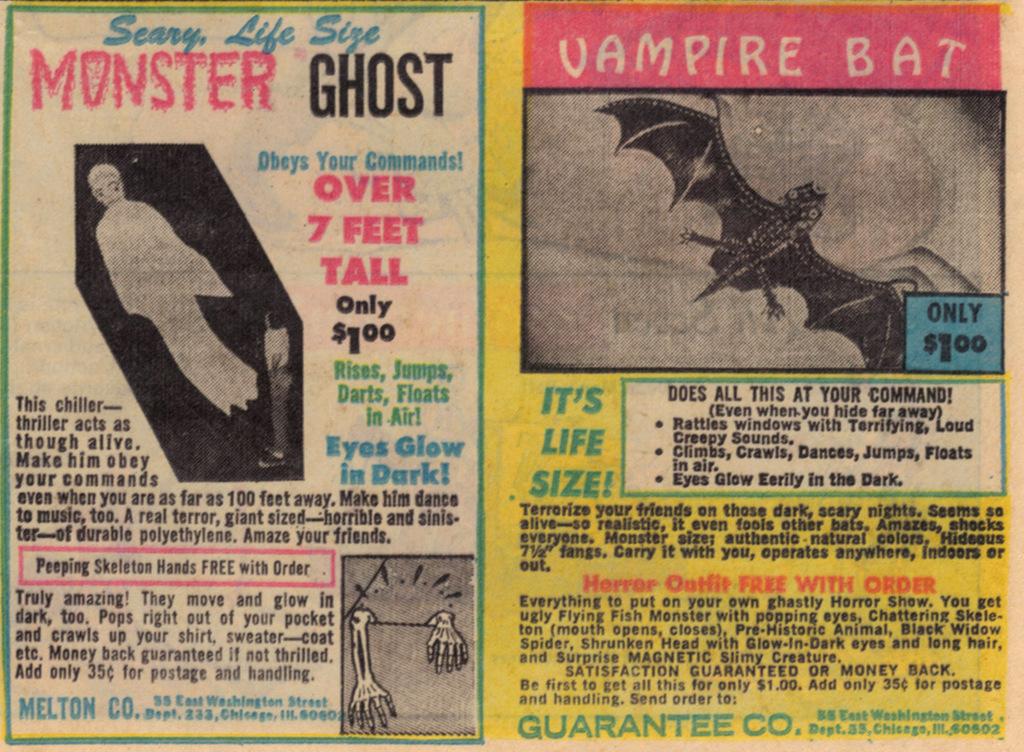What is the picture on the right of?
Ensure brevity in your answer.  Vampire bat. What type of monster is it?
Keep it short and to the point. Ghost. 